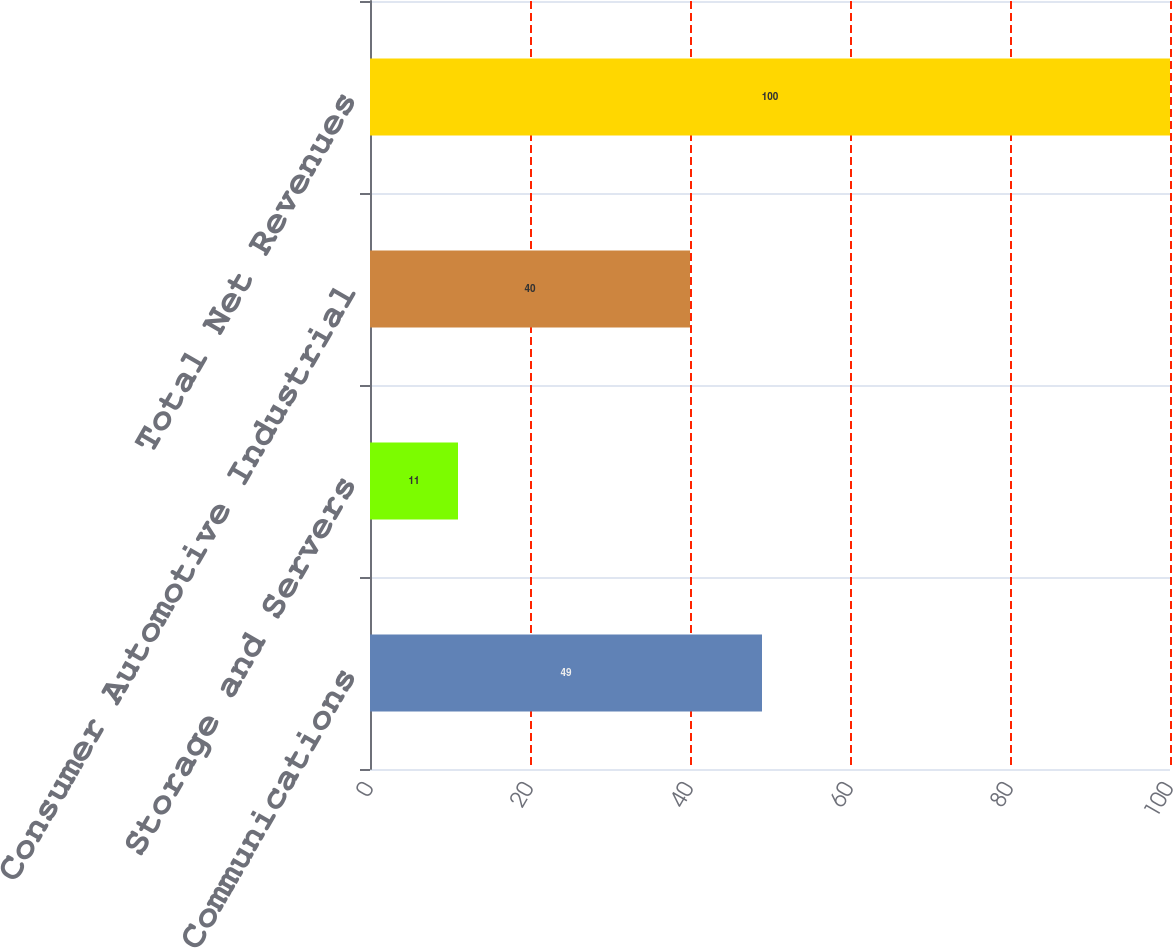Convert chart. <chart><loc_0><loc_0><loc_500><loc_500><bar_chart><fcel>Communications<fcel>Storage and Servers<fcel>Consumer Automotive Industrial<fcel>Total Net Revenues<nl><fcel>49<fcel>11<fcel>40<fcel>100<nl></chart> 